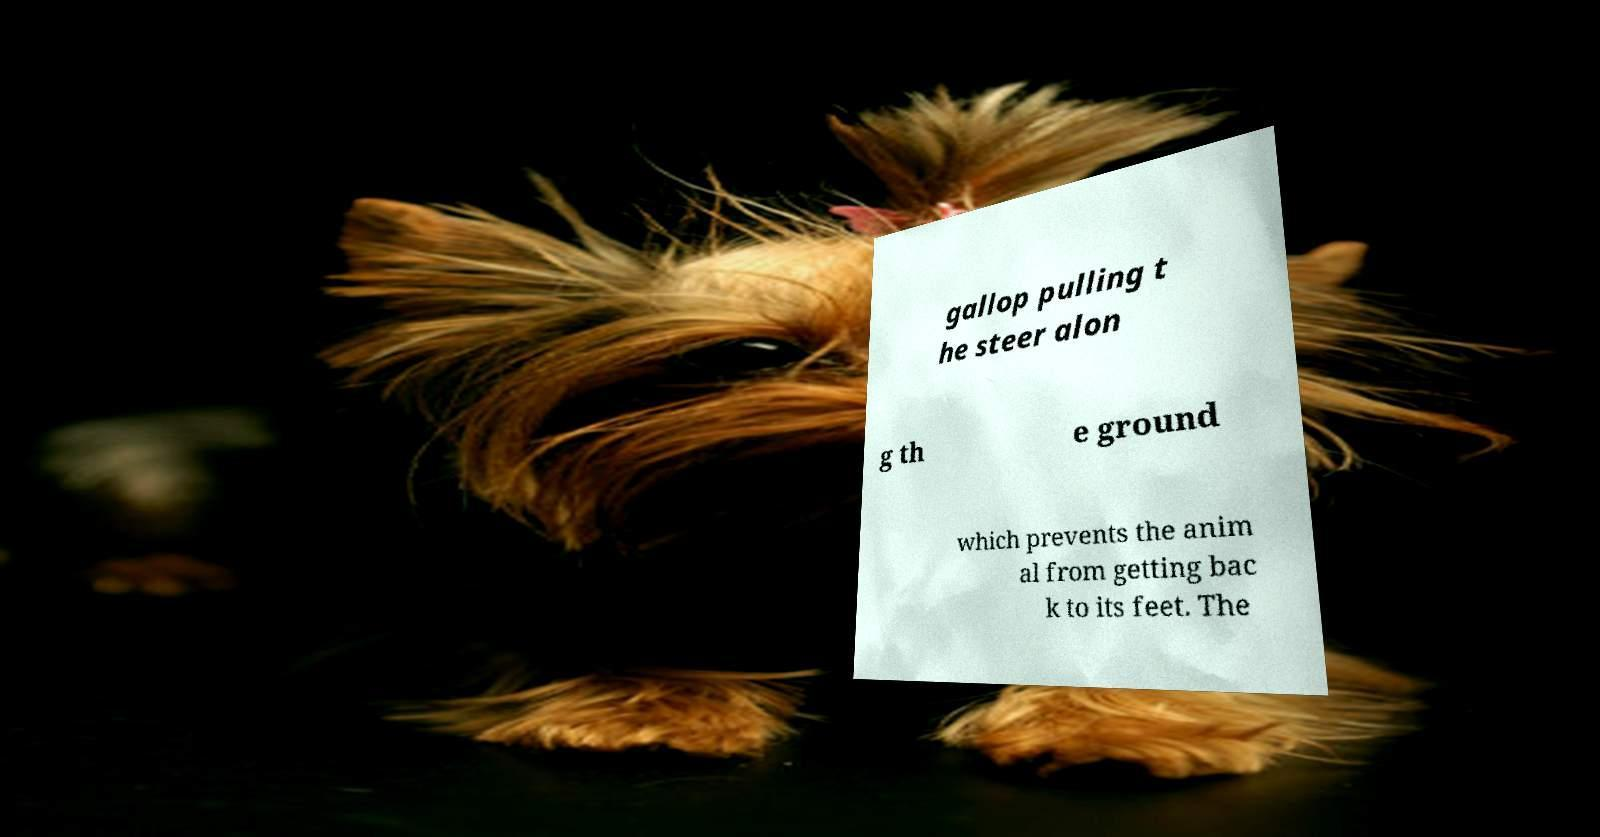Can you accurately transcribe the text from the provided image for me? gallop pulling t he steer alon g th e ground which prevents the anim al from getting bac k to its feet. The 